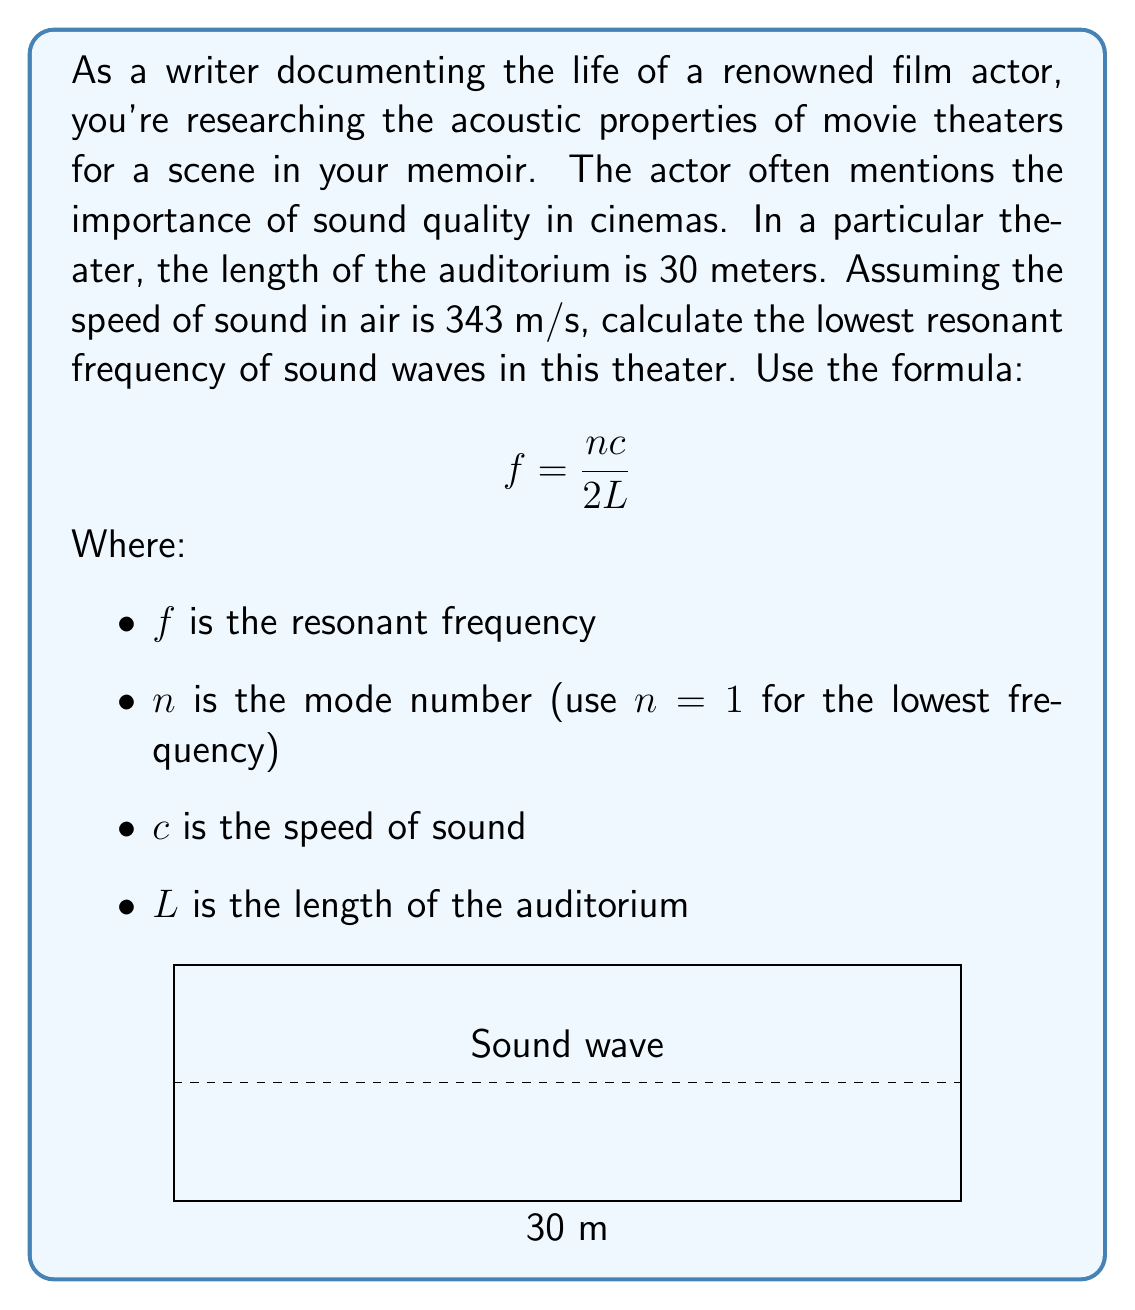Show me your answer to this math problem. To find the lowest resonant frequency, we'll use the given formula and substitute the known values:

1) We're given:
   $n = 1$ (lowest frequency)
   $c = 343$ m/s (speed of sound)
   $L = 30$ m (length of auditorium)

2) Substituting these into the formula:

   $$f = \frac{nc}{2L}$$

3) $$f = \frac{1 \times 343}{2 \times 30}$$

4) Simplifying:
   $$f = \frac{343}{60}$$

5) Calculating:
   $$f = 5.7166...$$

6) Rounding to two decimal places:
   $$f \approx 5.72 \text{ Hz}$$

This frequency represents the fundamental mode of standing waves in the auditorium, which is crucial for understanding how sound behaves in the space where the actor performs.
Answer: $5.72 \text{ Hz}$ 